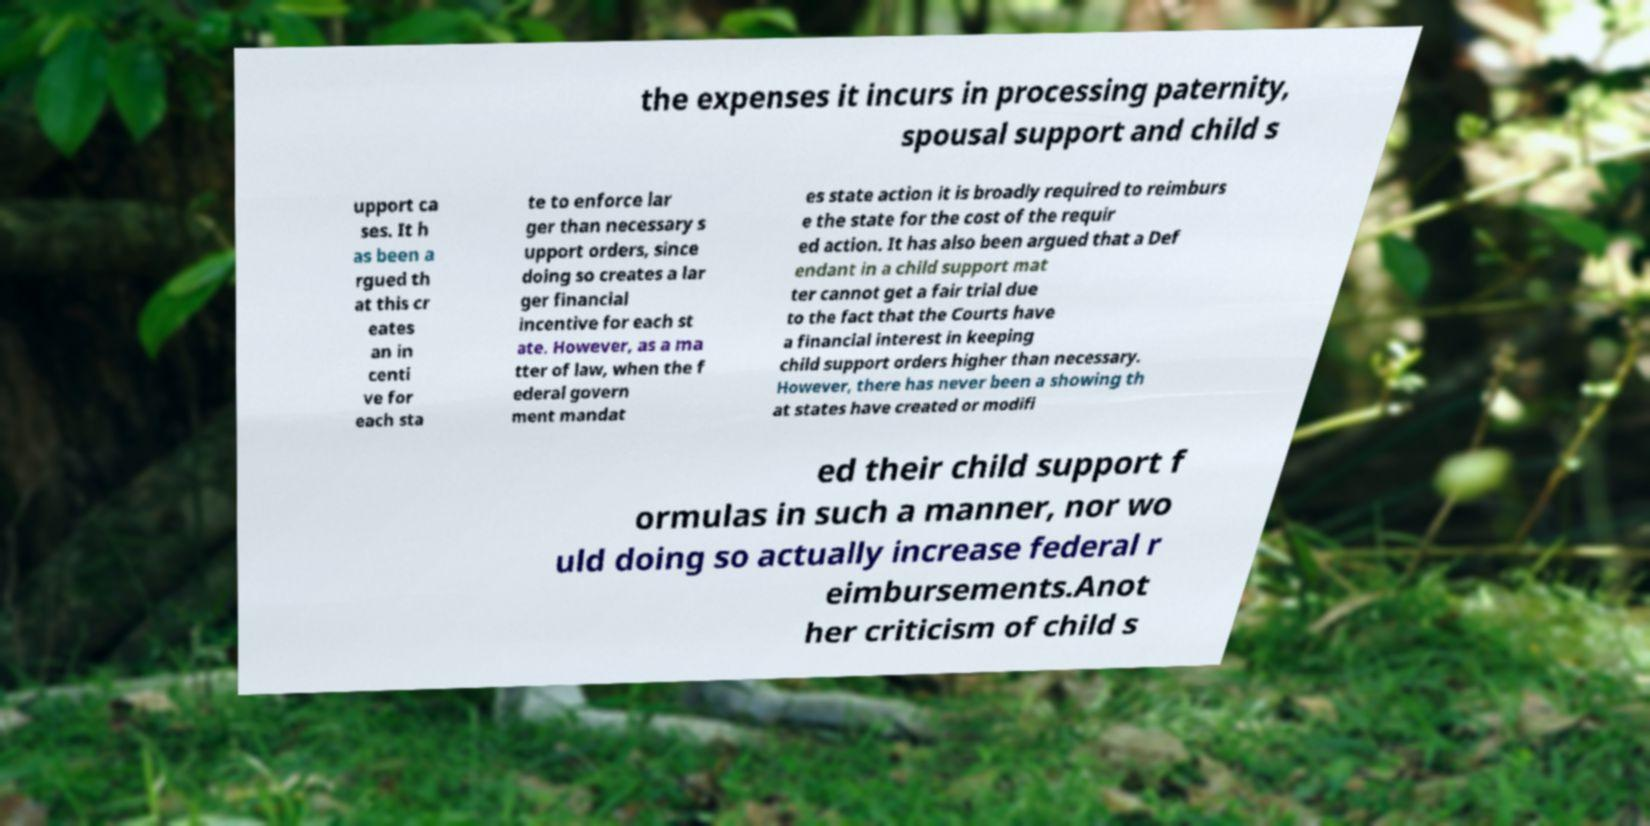I need the written content from this picture converted into text. Can you do that? the expenses it incurs in processing paternity, spousal support and child s upport ca ses. It h as been a rgued th at this cr eates an in centi ve for each sta te to enforce lar ger than necessary s upport orders, since doing so creates a lar ger financial incentive for each st ate. However, as a ma tter of law, when the f ederal govern ment mandat es state action it is broadly required to reimburs e the state for the cost of the requir ed action. It has also been argued that a Def endant in a child support mat ter cannot get a fair trial due to the fact that the Courts have a financial interest in keeping child support orders higher than necessary. However, there has never been a showing th at states have created or modifi ed their child support f ormulas in such a manner, nor wo uld doing so actually increase federal r eimbursements.Anot her criticism of child s 